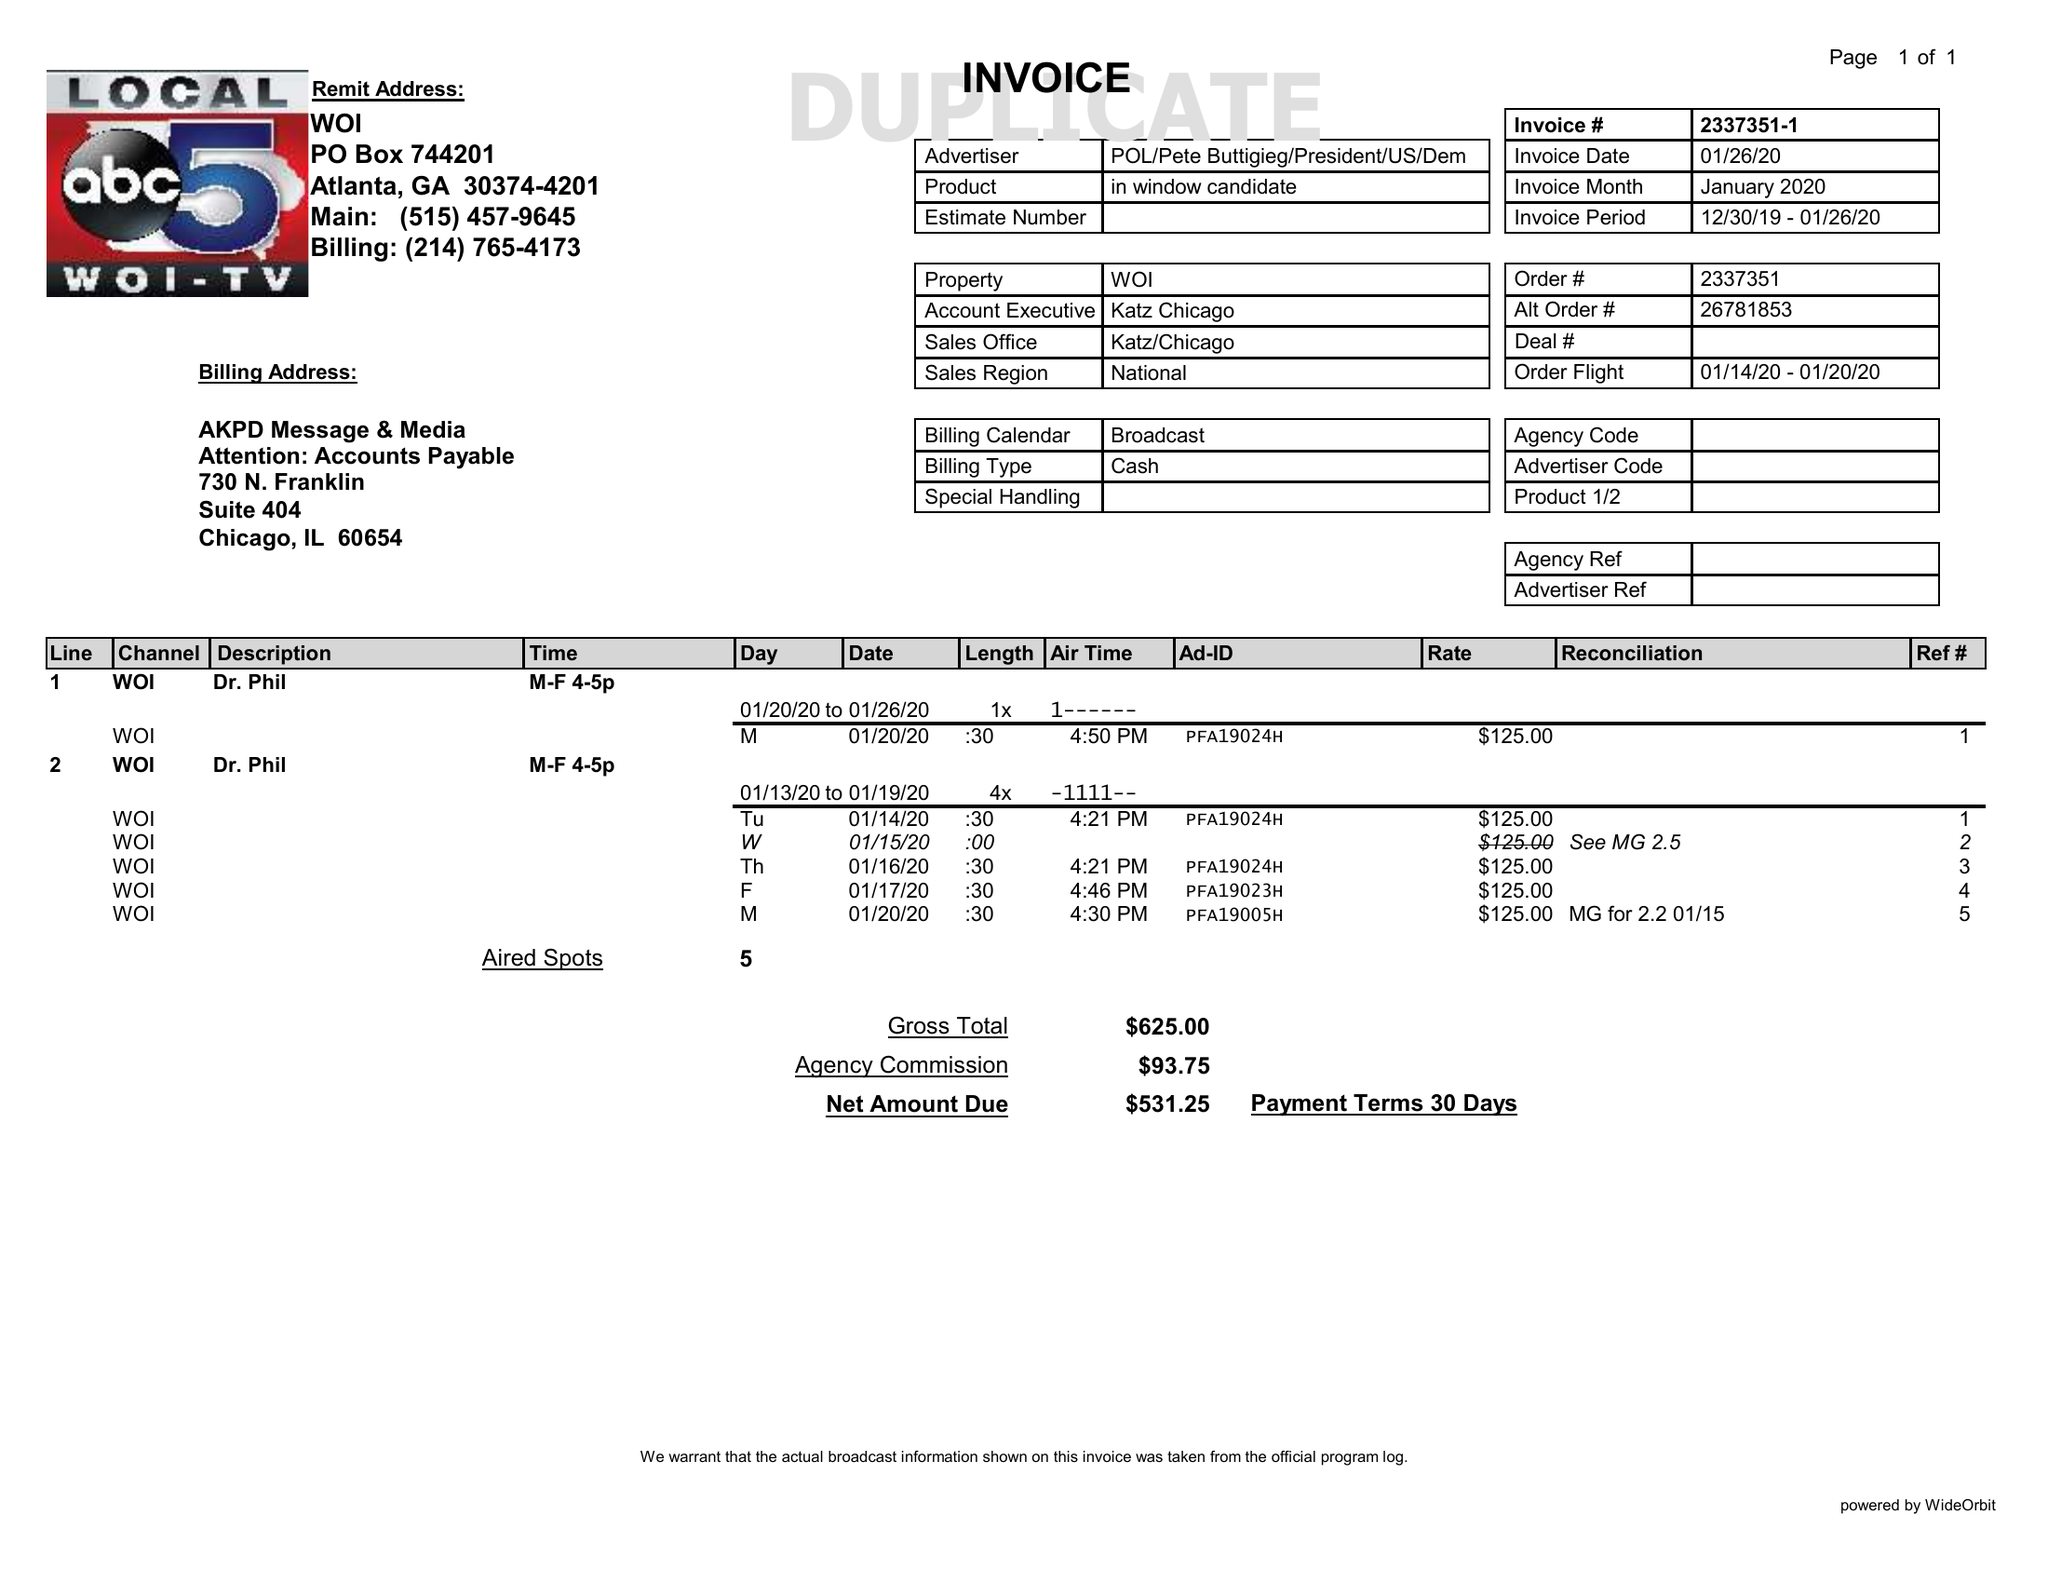What is the value for the flight_to?
Answer the question using a single word or phrase. 01/20/20 